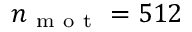Convert formula to latex. <formula><loc_0><loc_0><loc_500><loc_500>n _ { m o t } = 5 1 2</formula> 